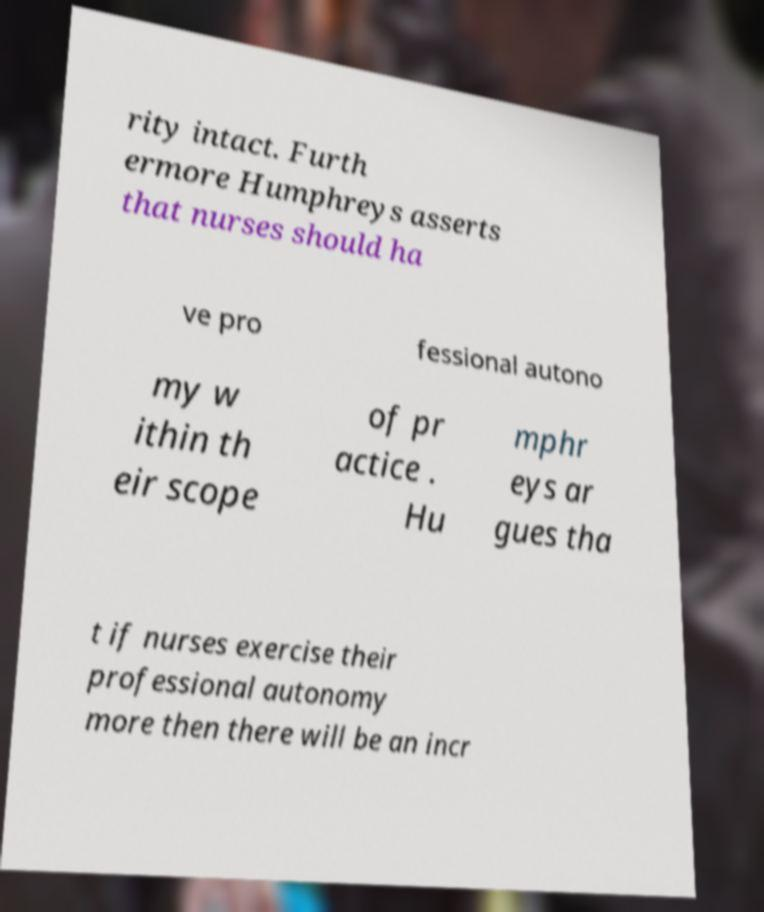Could you extract and type out the text from this image? rity intact. Furth ermore Humphreys asserts that nurses should ha ve pro fessional autono my w ithin th eir scope of pr actice . Hu mphr eys ar gues tha t if nurses exercise their professional autonomy more then there will be an incr 